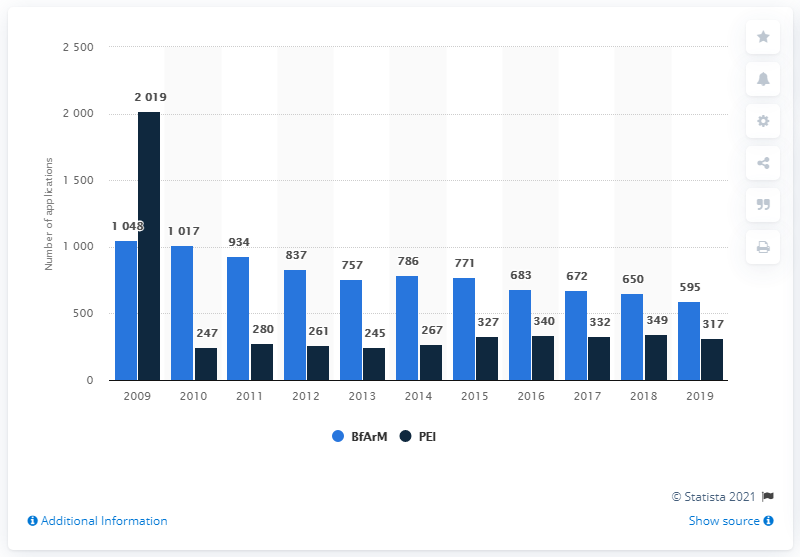Specify some key components in this picture. In 2019, a total of 595 applications were submitted to the Federal Institute for Drugs and Medical Devices (BfArM) and the Patent and Trademark Office (PEI). In 2019, a total of 317 applications were submitted to PEI. 